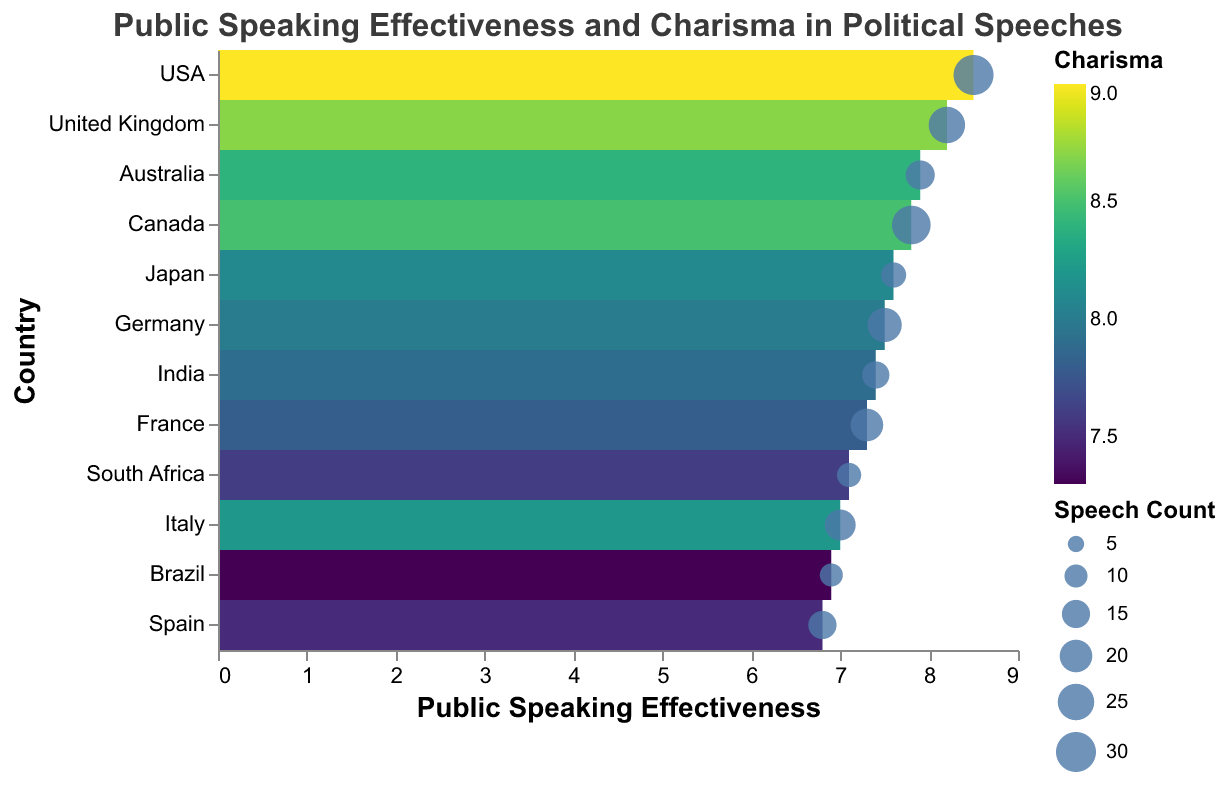What is the title of the figure? The title is displayed at the top of the figure and reads "Public Speaking Effectiveness and Charisma in Political Speeches".
Answer: "Public Speaking Effectiveness and Charisma in Political Speeches" How many countries are represented in the figure? Each country is represented by a row in the heatmap, and listing them reveals there are 12 countries.
Answer: 12 Which country has the highest public speaking effectiveness? By examining the x-axis values, the USA has the highest public speaking effectiveness at 8.5.
Answer: USA What is the range of charisma scores depicted in the heatmap? The color scale indicating charisma ranges from 7.3 (Brazil) to 9.0 (USA).
Answer: 7.3 to 9.0 Which country has both relatively high public speaking effectiveness and charisma? Looking at both the highest values on the x-axis and the most vibrant colors indicating charisma, the USA, with public speaking effectiveness of 8.5 and charisma of 9.0, stands out.
Answer: USA How does the public speaking effectiveness of Germany compare to that of Japan? Germany has a public speaking effectiveness of 7.5, while Japan has 7.6. Therefore, Japan's effectiveness is slightly higher than Germany’s.
Answer: Japan Which country has delivered the most political speeches? The size of the circles indicates speech count, with the largest circle representing the USA, which has delivered 30 speeches.
Answer: USA Are there any countries with the same public speaking effectiveness and charisma scores? By checking the x-axis and color scale for overlap, no two countries have identical values for both public speaking effectiveness and charisma.
Answer: No How does the charisma of India compare to that of South Africa? India has a charisma score of 7.9 while South Africa’s charisma is 7.6. Therefore, India has a slightly higher charisma score.
Answer: India Is there a country with a public speaking effectiveness below 7 with a relatively high charisma score? By referring to countries with public speaking effectiveness below 7 and examining their color intensity, Italy, with effectiveness of 7.0 and charisma of 8.2, fits the criteria.
Answer: Italy 